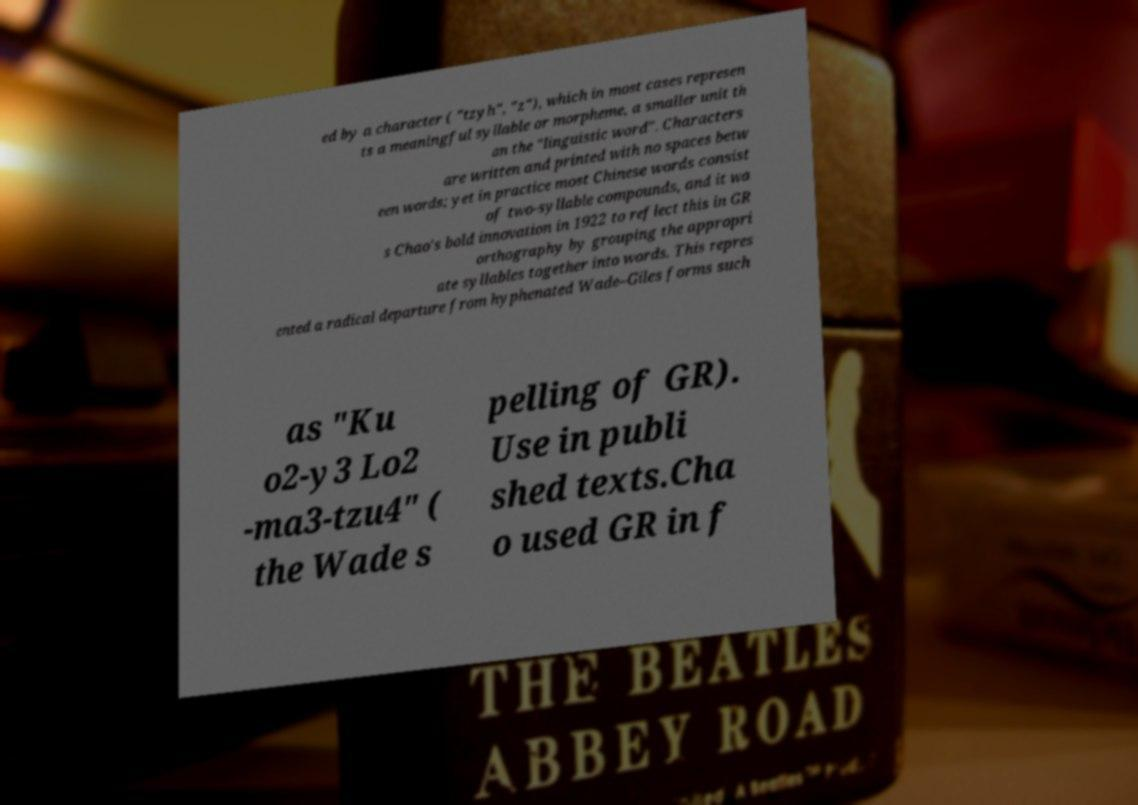Please read and relay the text visible in this image. What does it say? ed by a character ( "tzyh", "z"), which in most cases represen ts a meaningful syllable or morpheme, a smaller unit th an the "linguistic word". Characters are written and printed with no spaces betw een words; yet in practice most Chinese words consist of two-syllable compounds, and it wa s Chao's bold innovation in 1922 to reflect this in GR orthography by grouping the appropri ate syllables together into words. This repres ented a radical departure from hyphenated Wade–Giles forms such as "Ku o2-y3 Lo2 -ma3-tzu4" ( the Wade s pelling of GR). Use in publi shed texts.Cha o used GR in f 